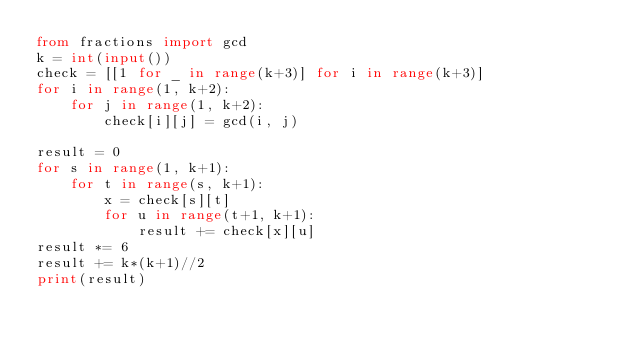<code> <loc_0><loc_0><loc_500><loc_500><_Python_>from fractions import gcd
k = int(input())
check = [[1 for _ in range(k+3)] for i in range(k+3)]
for i in range(1, k+2):
    for j in range(1, k+2):
        check[i][j] = gcd(i, j)

result = 0
for s in range(1, k+1):
    for t in range(s, k+1):
        x = check[s][t]
        for u in range(t+1, k+1): 
            result += check[x][u]
result *= 6
result += k*(k+1)//2
print(result)</code> 